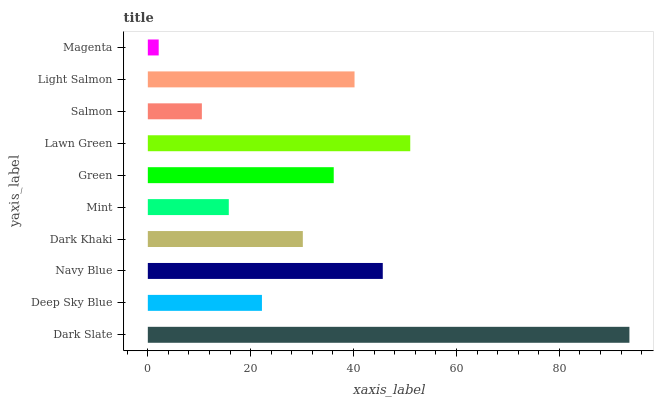Is Magenta the minimum?
Answer yes or no. Yes. Is Dark Slate the maximum?
Answer yes or no. Yes. Is Deep Sky Blue the minimum?
Answer yes or no. No. Is Deep Sky Blue the maximum?
Answer yes or no. No. Is Dark Slate greater than Deep Sky Blue?
Answer yes or no. Yes. Is Deep Sky Blue less than Dark Slate?
Answer yes or no. Yes. Is Deep Sky Blue greater than Dark Slate?
Answer yes or no. No. Is Dark Slate less than Deep Sky Blue?
Answer yes or no. No. Is Green the high median?
Answer yes or no. Yes. Is Dark Khaki the low median?
Answer yes or no. Yes. Is Navy Blue the high median?
Answer yes or no. No. Is Magenta the low median?
Answer yes or no. No. 